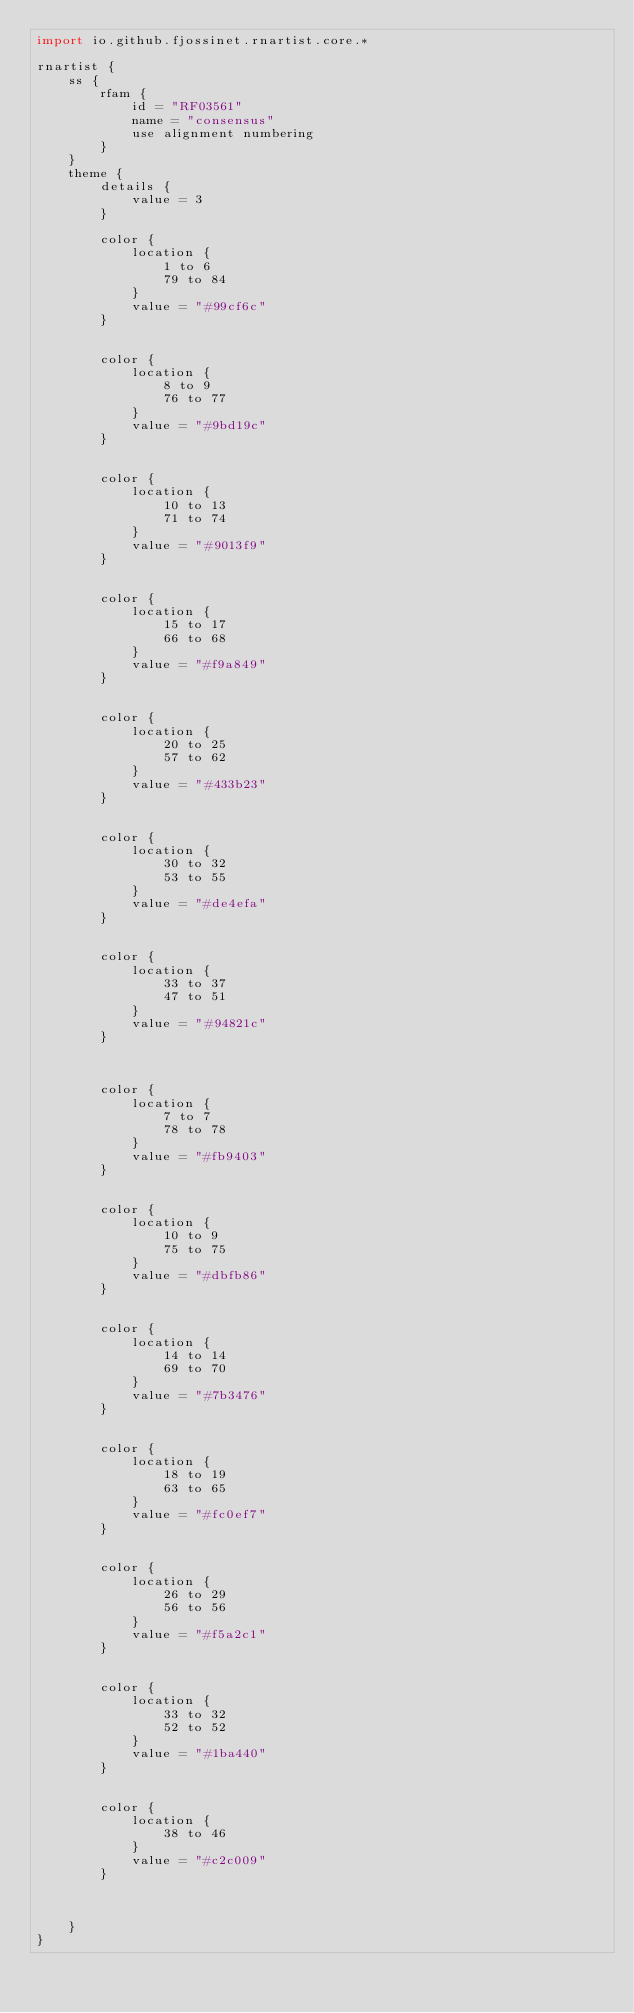<code> <loc_0><loc_0><loc_500><loc_500><_Kotlin_>import io.github.fjossinet.rnartist.core.*      

rnartist {
    ss {
        rfam {
            id = "RF03561"
            name = "consensus"
            use alignment numbering
        }
    }
    theme {
        details { 
            value = 3
        }

        color {
            location {
                1 to 6
                79 to 84
            }
            value = "#99cf6c"
        }


        color {
            location {
                8 to 9
                76 to 77
            }
            value = "#9bd19c"
        }


        color {
            location {
                10 to 13
                71 to 74
            }
            value = "#9013f9"
        }


        color {
            location {
                15 to 17
                66 to 68
            }
            value = "#f9a849"
        }


        color {
            location {
                20 to 25
                57 to 62
            }
            value = "#433b23"
        }


        color {
            location {
                30 to 32
                53 to 55
            }
            value = "#de4efa"
        }


        color {
            location {
                33 to 37
                47 to 51
            }
            value = "#94821c"
        }



        color {
            location {
                7 to 7
                78 to 78
            }
            value = "#fb9403"
        }


        color {
            location {
                10 to 9
                75 to 75
            }
            value = "#dbfb86"
        }


        color {
            location {
                14 to 14
                69 to 70
            }
            value = "#7b3476"
        }


        color {
            location {
                18 to 19
                63 to 65
            }
            value = "#fc0ef7"
        }


        color {
            location {
                26 to 29
                56 to 56
            }
            value = "#f5a2c1"
        }


        color {
            location {
                33 to 32
                52 to 52
            }
            value = "#1ba440"
        }


        color {
            location {
                38 to 46
            }
            value = "#c2c009"
        }



    }
}           </code> 